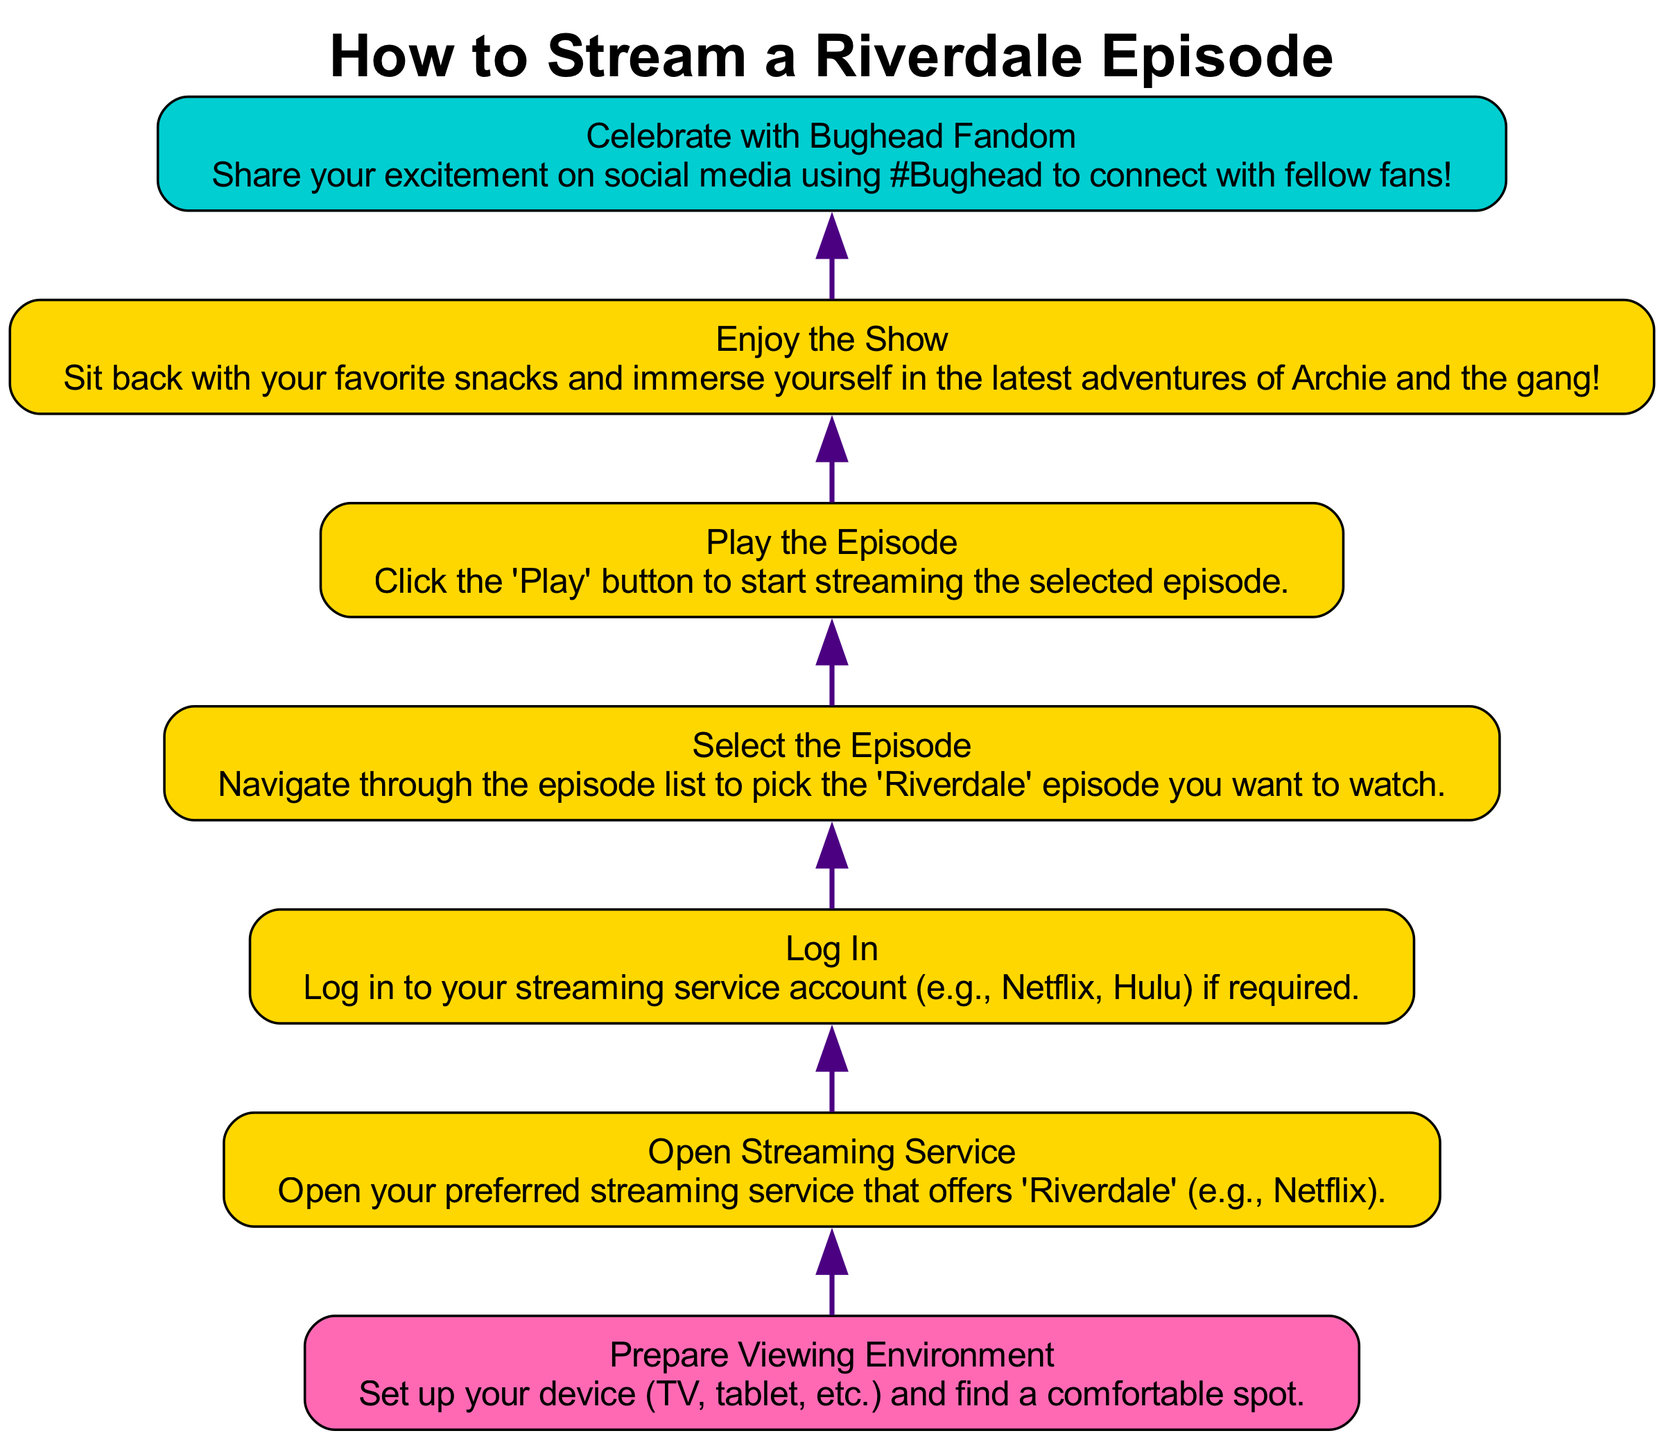What is the first step in the diagram? The first step, as indicated at the bottom of the flowchart, is “Prepare Viewing Environment.” This means it is the initial action to take before streaming an episode.
Answer: Prepare Viewing Environment How many total steps are there in the diagram? The diagram lists a total of 7 steps which guide you through the process of streaming a Riverdale episode.
Answer: 7 What is the final action to take after watching an episode? The final action you should take, as seen at the top of the flowchart, is to “Celebrate with Bughead Fandom.” This encourages fans to share their excitement online.
Answer: Celebrate with Bughead Fandom Which step comes directly after playing the episode? After “Play the Episode,” the next step is “Enjoy the Show.” This indicates that once the episode is playing, viewers should relax and enjoy it.
Answer: Enjoy the Show What is required before selecting an episode? Before selecting an episode, the diagram indicates that you must “Open Streaming Service.” This is a necessary step to access the episodes available for viewing.
Answer: Open Streaming Service Why do you need to log in before streaming an episode? Logging in is necessary, as per the diagram, to access the streaming service account, which is crucial for playing the episode. Without logging in, you may not have access to the content.
Answer: To access streaming service accounts What is the step before “Select the Episode”? The step prior to “Select the Episode” is “Log In.” This means you need to log into your streaming service to proceed to choose which episode to watch.
Answer: Log In 